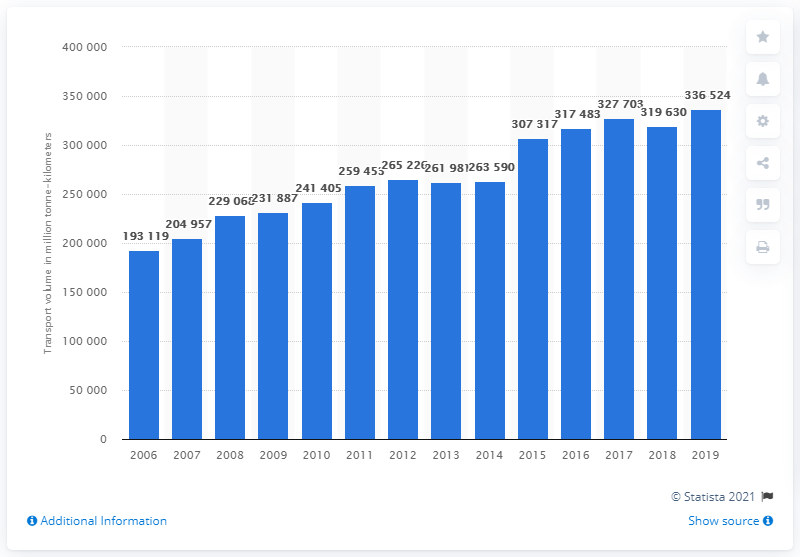Specify some key components in this picture. In 2019, a total of 336,524 units of freight were transported in Turkey. 